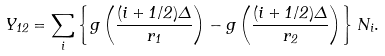<formula> <loc_0><loc_0><loc_500><loc_500>Y _ { 1 2 } = \sum _ { i } ^ { \, } \left \{ g \left ( { \frac { ( i + 1 / 2 ) \Delta } { r _ { 1 } } } \right ) - g \left ( { \frac { ( i + 1 / 2 ) \Delta } { r _ { 2 } } } \right ) \right \} N _ { i } .</formula> 